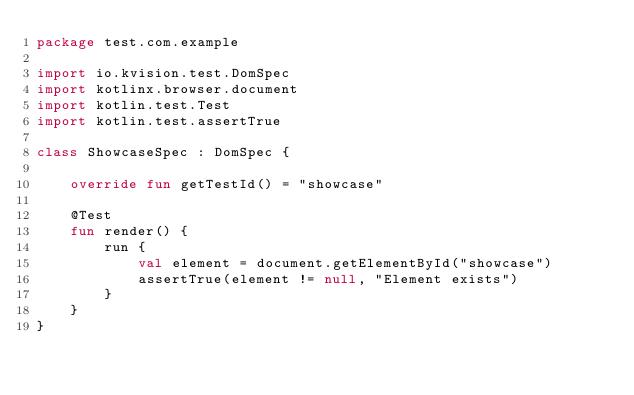<code> <loc_0><loc_0><loc_500><loc_500><_Kotlin_>package test.com.example

import io.kvision.test.DomSpec
import kotlinx.browser.document
import kotlin.test.Test
import kotlin.test.assertTrue

class ShowcaseSpec : DomSpec {

    override fun getTestId() = "showcase"

    @Test
    fun render() {
        run {
            val element = document.getElementById("showcase")
            assertTrue(element != null, "Element exists")
        }
    }
}
</code> 